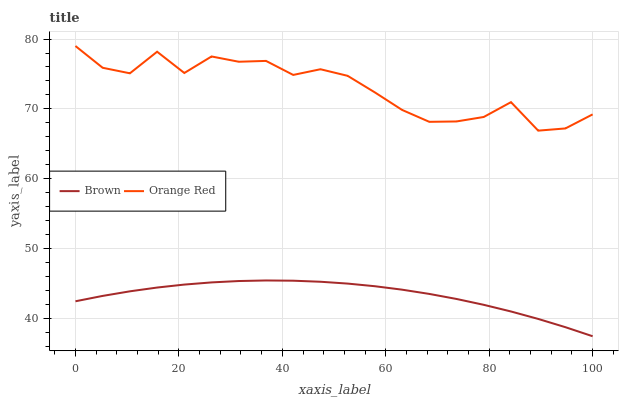Does Orange Red have the minimum area under the curve?
Answer yes or no. No. Is Orange Red the smoothest?
Answer yes or no. No. Does Orange Red have the lowest value?
Answer yes or no. No. Is Brown less than Orange Red?
Answer yes or no. Yes. Is Orange Red greater than Brown?
Answer yes or no. Yes. Does Brown intersect Orange Red?
Answer yes or no. No. 